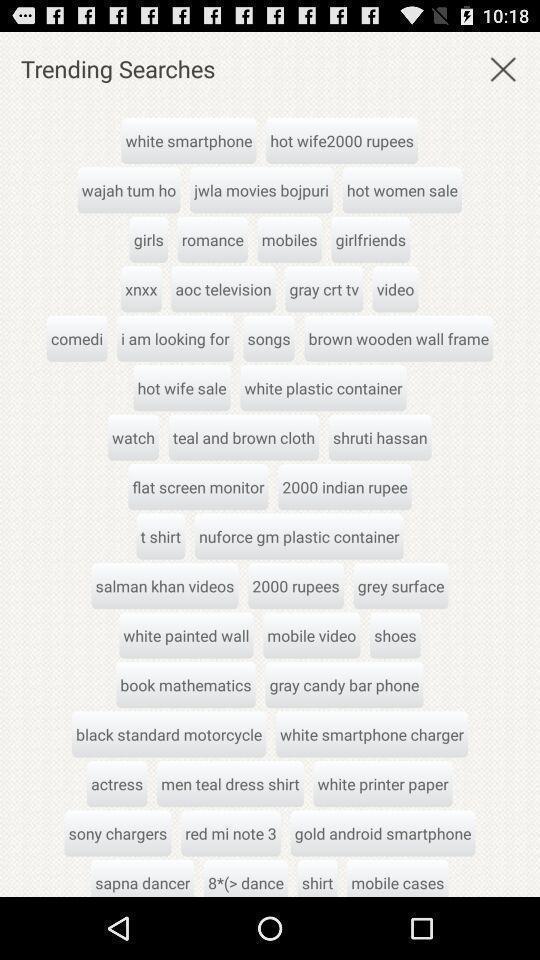Give me a narrative description of this picture. Trending searches. 